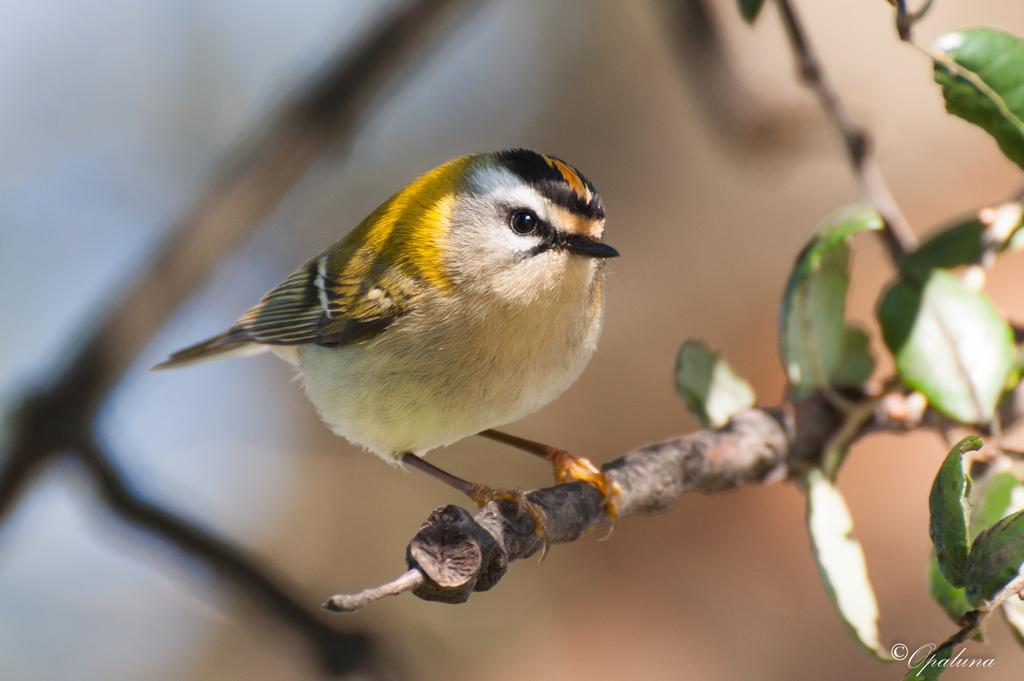What type of animal is in the image? There is a bird in the image. Can you describe the bird's appearance? The bird has black and yellow coloring. Where is the bird located in the image? The bird is on a branch of a plant. What can be seen on the right side of the image? There is a tree or a plant on the right side of the image. How many chairs are visible in the image? There are no chairs present in the image. What type of debt is the bird trying to pay off in the image? There is no mention of debt in the image; it features a bird on a branch of a plant. 